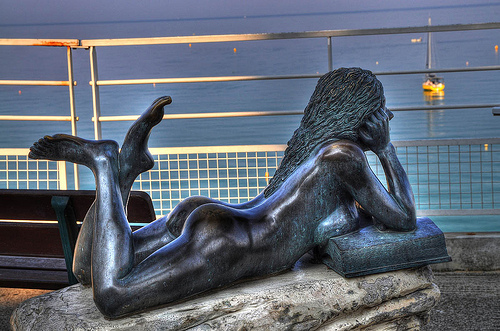<image>
Is the girl on the rock? Yes. Looking at the image, I can see the girl is positioned on top of the rock, with the rock providing support. 